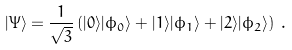<formula> <loc_0><loc_0><loc_500><loc_500>| \Psi \rangle = \frac { 1 } { \sqrt { 3 } } \left ( | 0 \rangle | \phi _ { 0 } \rangle + | 1 \rangle | \phi _ { 1 } \rangle + | 2 \rangle | \phi _ { 2 } \rangle \right ) \, .</formula> 